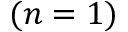<formula> <loc_0><loc_0><loc_500><loc_500>( n = 1 )</formula> 